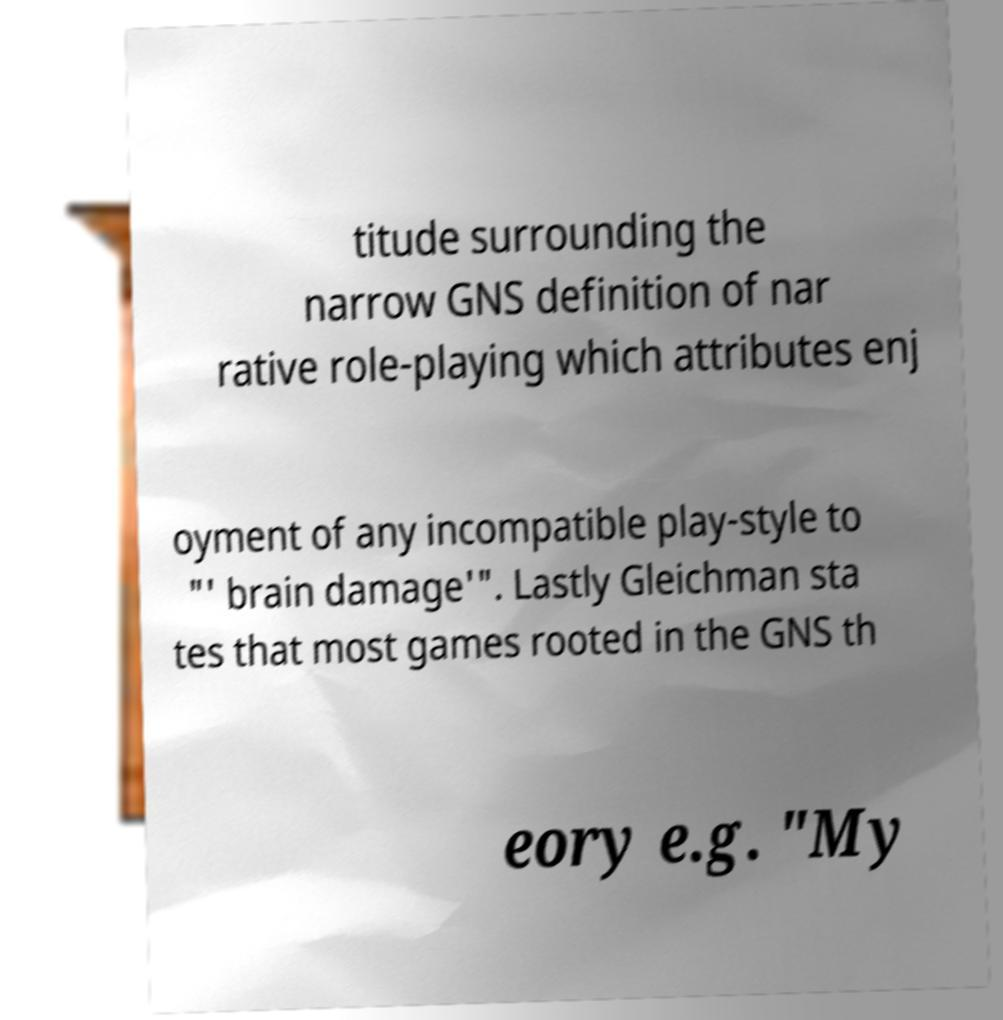Could you extract and type out the text from this image? titude surrounding the narrow GNS definition of nar rative role-playing which attributes enj oyment of any incompatible play-style to "' brain damage'". Lastly Gleichman sta tes that most games rooted in the GNS th eory e.g. "My 